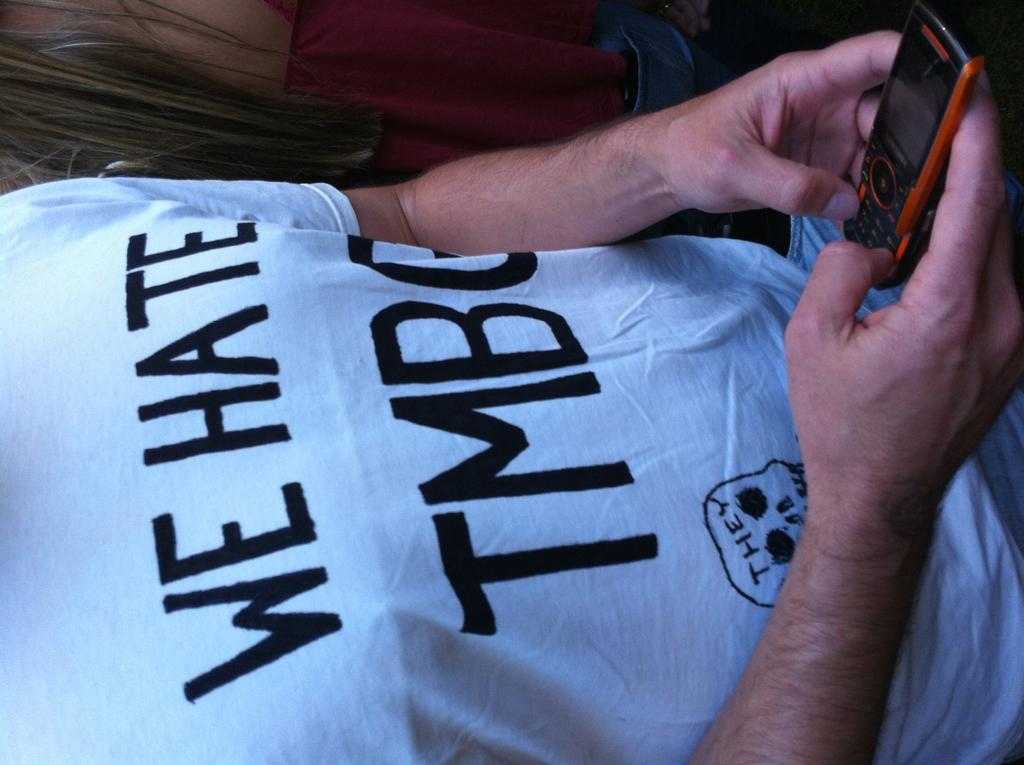Provide a one-sentence caption for the provided image. The man's tee shirt expresses that he hates a group or person with a name that starts with TMB. 